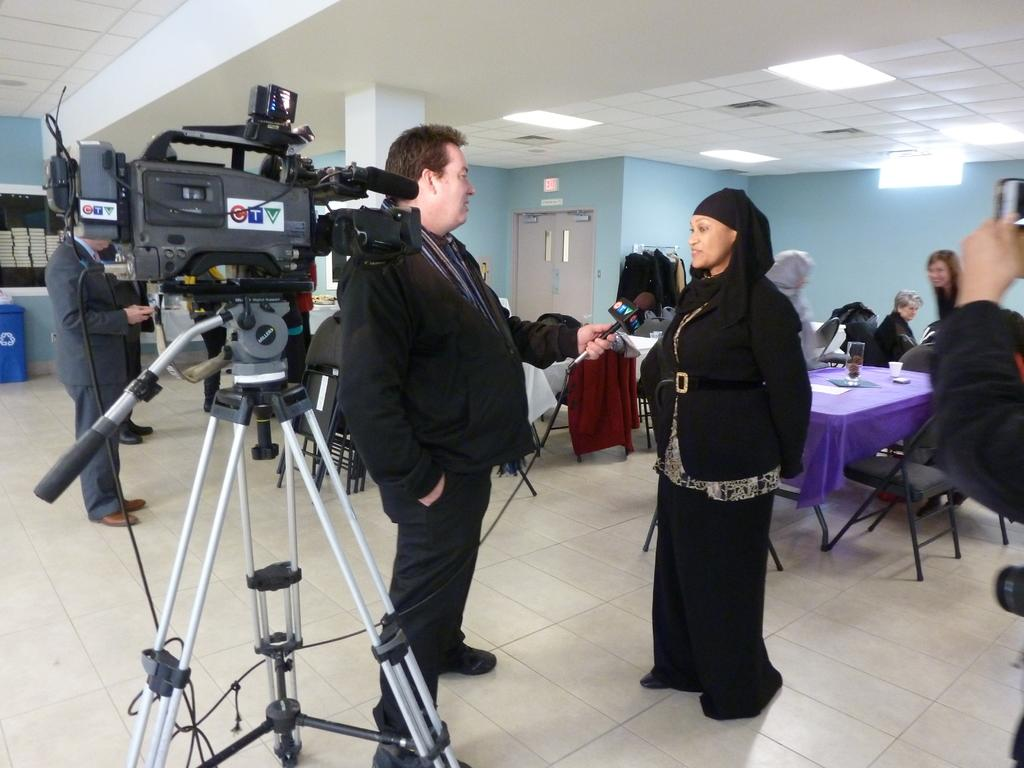How many people are in the image? There is a group of people in the image. What equipment is present in the image? There is a camera and a tripod stand in the image. What furniture is visible in the image? There is a table and a chair in the image. What object might be used for drinking in the image? There is a glass in the image. What source of illumination is present in the image? There is a light in the image. How does the spy communicate with the group of people in the image? There is no indication of a spy or any communication in the image; it only shows a group of people, a camera, a tripod stand, a table, a chair, a glass, and a light. 